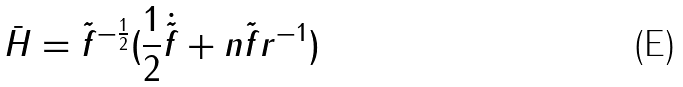Convert formula to latex. <formula><loc_0><loc_0><loc_500><loc_500>\bar { H } = \tilde { f } ^ { - \frac { 1 } { 2 } } ( \frac { 1 } { 2 } \dot { \tilde { f } } + n \tilde { f } r ^ { - 1 } )</formula> 